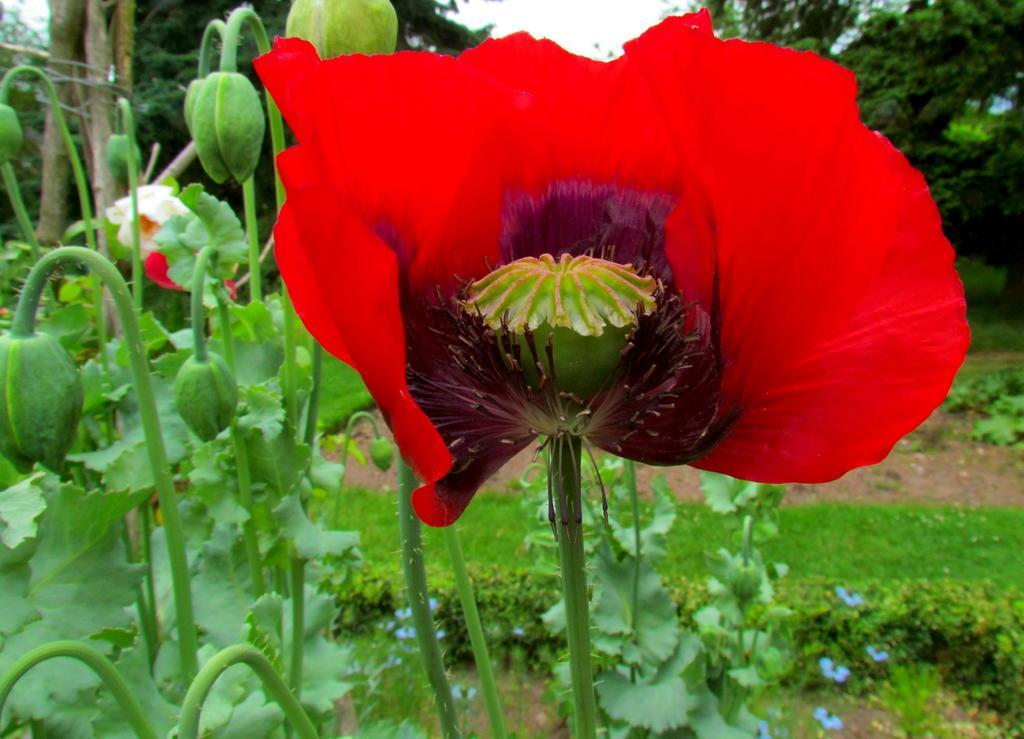Please provide a concise description of this image. In this image we can see some flowers and buds on the plants, there are some trees and the grass, also we can see the sky. 